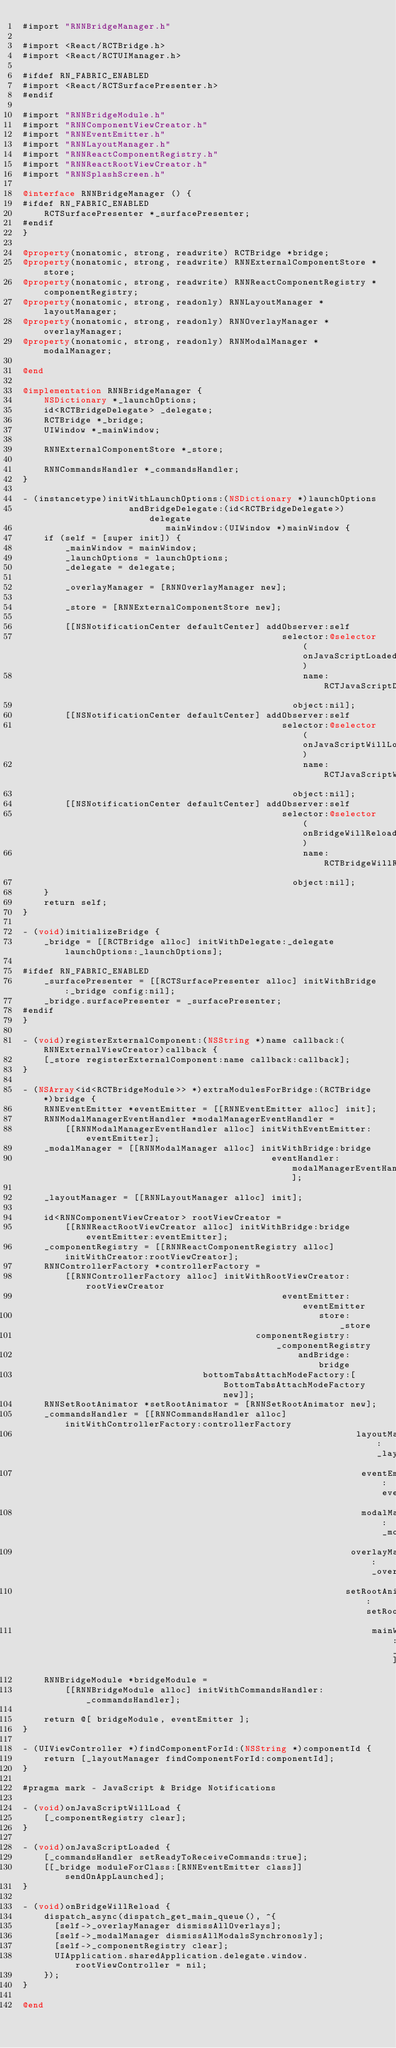<code> <loc_0><loc_0><loc_500><loc_500><_ObjectiveC_>#import "RNNBridgeManager.h"

#import <React/RCTBridge.h>
#import <React/RCTUIManager.h>

#ifdef RN_FABRIC_ENABLED
#import <React/RCTSurfacePresenter.h>
#endif

#import "RNNBridgeModule.h"
#import "RNNComponentViewCreator.h"
#import "RNNEventEmitter.h"
#import "RNNLayoutManager.h"
#import "RNNReactComponentRegistry.h"
#import "RNNReactRootViewCreator.h"
#import "RNNSplashScreen.h"

@interface RNNBridgeManager () {
#ifdef RN_FABRIC_ENABLED
    RCTSurfacePresenter *_surfacePresenter;
#endif
}

@property(nonatomic, strong, readwrite) RCTBridge *bridge;
@property(nonatomic, strong, readwrite) RNNExternalComponentStore *store;
@property(nonatomic, strong, readwrite) RNNReactComponentRegistry *componentRegistry;
@property(nonatomic, strong, readonly) RNNLayoutManager *layoutManager;
@property(nonatomic, strong, readonly) RNNOverlayManager *overlayManager;
@property(nonatomic, strong, readonly) RNNModalManager *modalManager;

@end

@implementation RNNBridgeManager {
    NSDictionary *_launchOptions;
    id<RCTBridgeDelegate> _delegate;
    RCTBridge *_bridge;
    UIWindow *_mainWindow;

    RNNExternalComponentStore *_store;

    RNNCommandsHandler *_commandsHandler;
}

- (instancetype)initWithLaunchOptions:(NSDictionary *)launchOptions
                    andBridgeDelegate:(id<RCTBridgeDelegate>)delegate
                           mainWindow:(UIWindow *)mainWindow {
    if (self = [super init]) {
        _mainWindow = mainWindow;
        _launchOptions = launchOptions;
        _delegate = delegate;

        _overlayManager = [RNNOverlayManager new];

        _store = [RNNExternalComponentStore new];

        [[NSNotificationCenter defaultCenter] addObserver:self
                                                 selector:@selector(onJavaScriptLoaded)
                                                     name:RCTJavaScriptDidLoadNotification
                                                   object:nil];
        [[NSNotificationCenter defaultCenter] addObserver:self
                                                 selector:@selector(onJavaScriptWillLoad)
                                                     name:RCTJavaScriptWillStartLoadingNotification
                                                   object:nil];
        [[NSNotificationCenter defaultCenter] addObserver:self
                                                 selector:@selector(onBridgeWillReload)
                                                     name:RCTBridgeWillReloadNotification
                                                   object:nil];
    }
    return self;
}

- (void)initializeBridge {
    _bridge = [[RCTBridge alloc] initWithDelegate:_delegate launchOptions:_launchOptions];

#ifdef RN_FABRIC_ENABLED
    _surfacePresenter = [[RCTSurfacePresenter alloc] initWithBridge:_bridge config:nil];
    _bridge.surfacePresenter = _surfacePresenter;
#endif
}

- (void)registerExternalComponent:(NSString *)name callback:(RNNExternalViewCreator)callback {
    [_store registerExternalComponent:name callback:callback];
}

- (NSArray<id<RCTBridgeModule>> *)extraModulesForBridge:(RCTBridge *)bridge {
    RNNEventEmitter *eventEmitter = [[RNNEventEmitter alloc] init];
    RNNModalManagerEventHandler *modalManagerEventHandler =
        [[RNNModalManagerEventHandler alloc] initWithEventEmitter:eventEmitter];
    _modalManager = [[RNNModalManager alloc] initWithBridge:bridge
                                               eventHandler:modalManagerEventHandler];

    _layoutManager = [[RNNLayoutManager alloc] init];

    id<RNNComponentViewCreator> rootViewCreator =
        [[RNNReactRootViewCreator alloc] initWithBridge:bridge eventEmitter:eventEmitter];
    _componentRegistry = [[RNNReactComponentRegistry alloc] initWithCreator:rootViewCreator];
    RNNControllerFactory *controllerFactory =
        [[RNNControllerFactory alloc] initWithRootViewCreator:rootViewCreator
                                                 eventEmitter:eventEmitter
                                                        store:_store
                                            componentRegistry:_componentRegistry
                                                    andBridge:bridge
                                  bottomTabsAttachModeFactory:[BottomTabsAttachModeFactory new]];
    RNNSetRootAnimator *setRootAnimator = [RNNSetRootAnimator new];
    _commandsHandler = [[RNNCommandsHandler alloc] initWithControllerFactory:controllerFactory
                                                               layoutManager:_layoutManager
                                                                eventEmitter:eventEmitter
                                                                modalManager:_modalManager
                                                              overlayManager:_overlayManager
                                                             setRootAnimator:setRootAnimator
                                                                  mainWindow:_mainWindow];
    RNNBridgeModule *bridgeModule =
        [[RNNBridgeModule alloc] initWithCommandsHandler:_commandsHandler];

    return @[ bridgeModule, eventEmitter ];
}

- (UIViewController *)findComponentForId:(NSString *)componentId {
    return [_layoutManager findComponentForId:componentId];
}

#pragma mark - JavaScript & Bridge Notifications

- (void)onJavaScriptWillLoad {
    [_componentRegistry clear];
}

- (void)onJavaScriptLoaded {
    [_commandsHandler setReadyToReceiveCommands:true];
    [[_bridge moduleForClass:[RNNEventEmitter class]] sendOnAppLaunched];
}

- (void)onBridgeWillReload {
    dispatch_async(dispatch_get_main_queue(), ^{
      [self->_overlayManager dismissAllOverlays];
      [self->_modalManager dismissAllModalsSynchronosly];
      [self->_componentRegistry clear];
      UIApplication.sharedApplication.delegate.window.rootViewController = nil;
    });
}

@end
</code> 